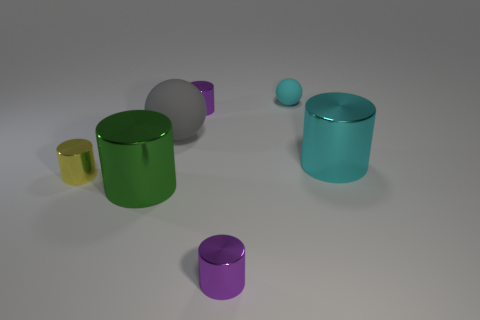Subtract all big green metallic cylinders. How many cylinders are left? 4 Add 2 cyan balls. How many objects exist? 9 Subtract all purple cylinders. How many cylinders are left? 3 Subtract all cylinders. How many objects are left? 2 Subtract all brown balls. How many purple cylinders are left? 2 Subtract 1 yellow cylinders. How many objects are left? 6 Subtract 2 cylinders. How many cylinders are left? 3 Subtract all red cylinders. Subtract all blue spheres. How many cylinders are left? 5 Subtract all big cylinders. Subtract all green objects. How many objects are left? 4 Add 5 big cyan metallic things. How many big cyan metallic things are left? 6 